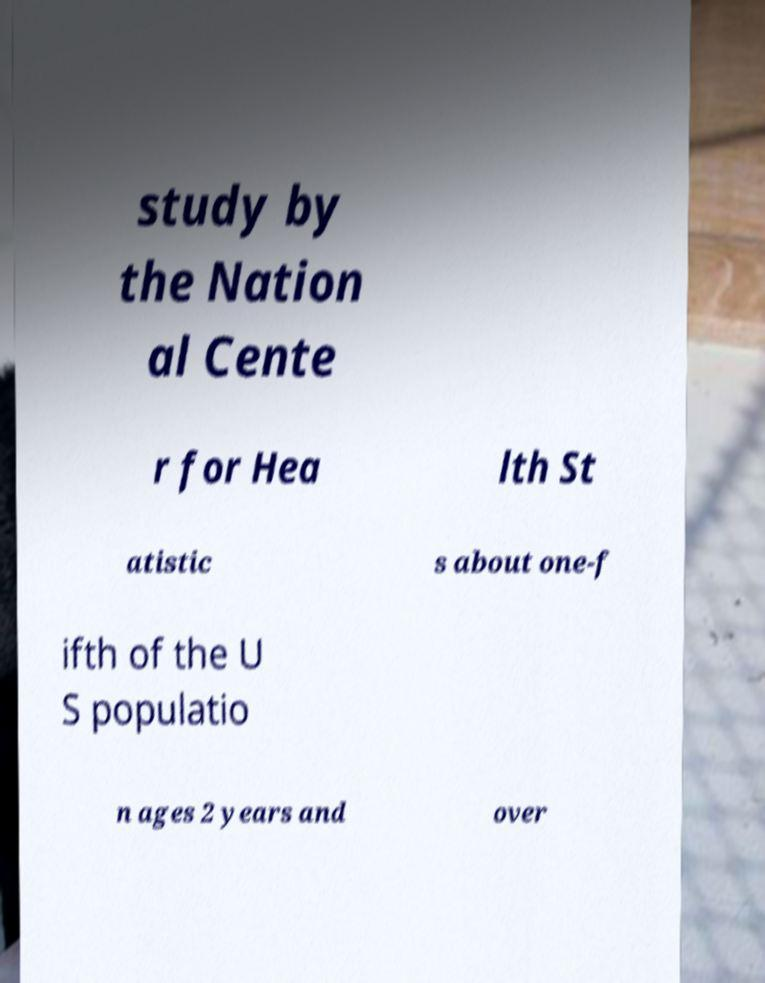What messages or text are displayed in this image? I need them in a readable, typed format. study by the Nation al Cente r for Hea lth St atistic s about one-f ifth of the U S populatio n ages 2 years and over 